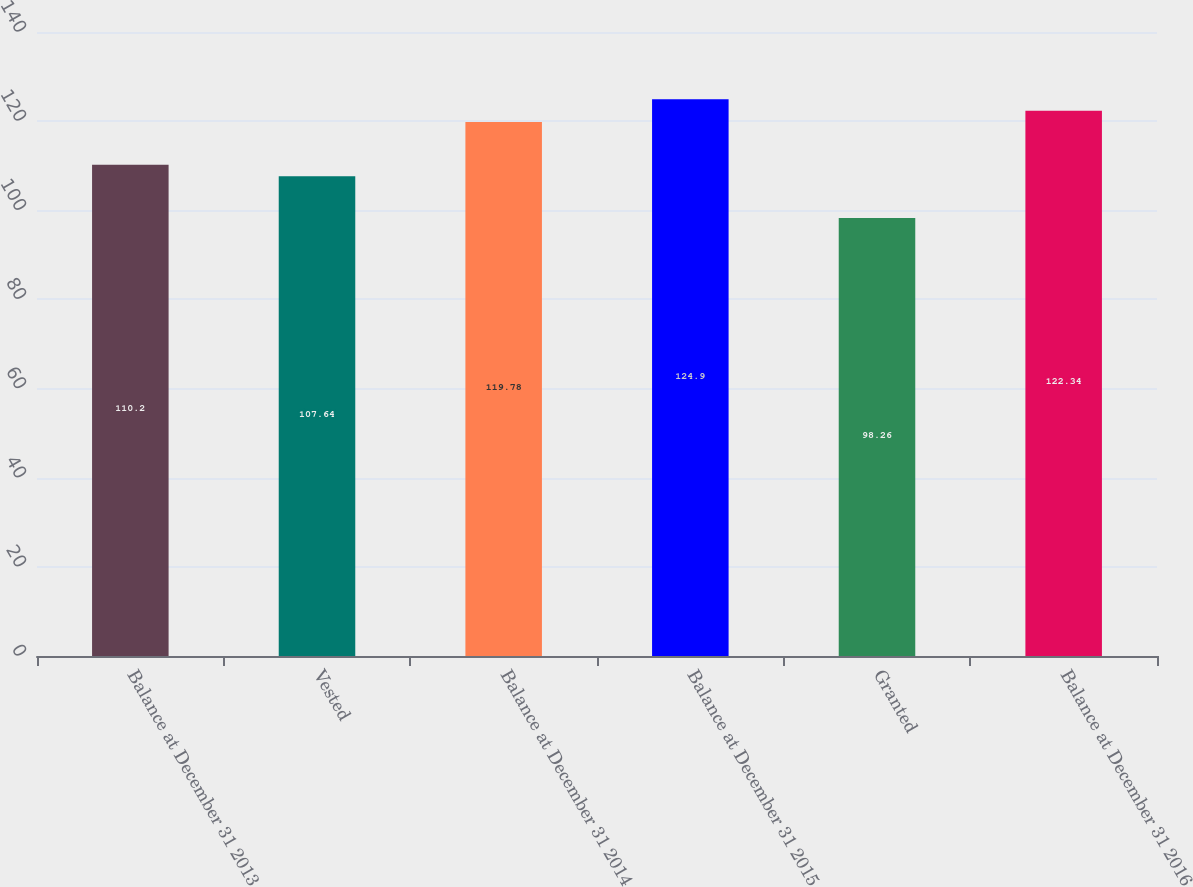Convert chart to OTSL. <chart><loc_0><loc_0><loc_500><loc_500><bar_chart><fcel>Balance at December 31 2013<fcel>Vested<fcel>Balance at December 31 2014<fcel>Balance at December 31 2015<fcel>Granted<fcel>Balance at December 31 2016<nl><fcel>110.2<fcel>107.64<fcel>119.78<fcel>124.9<fcel>98.26<fcel>122.34<nl></chart> 